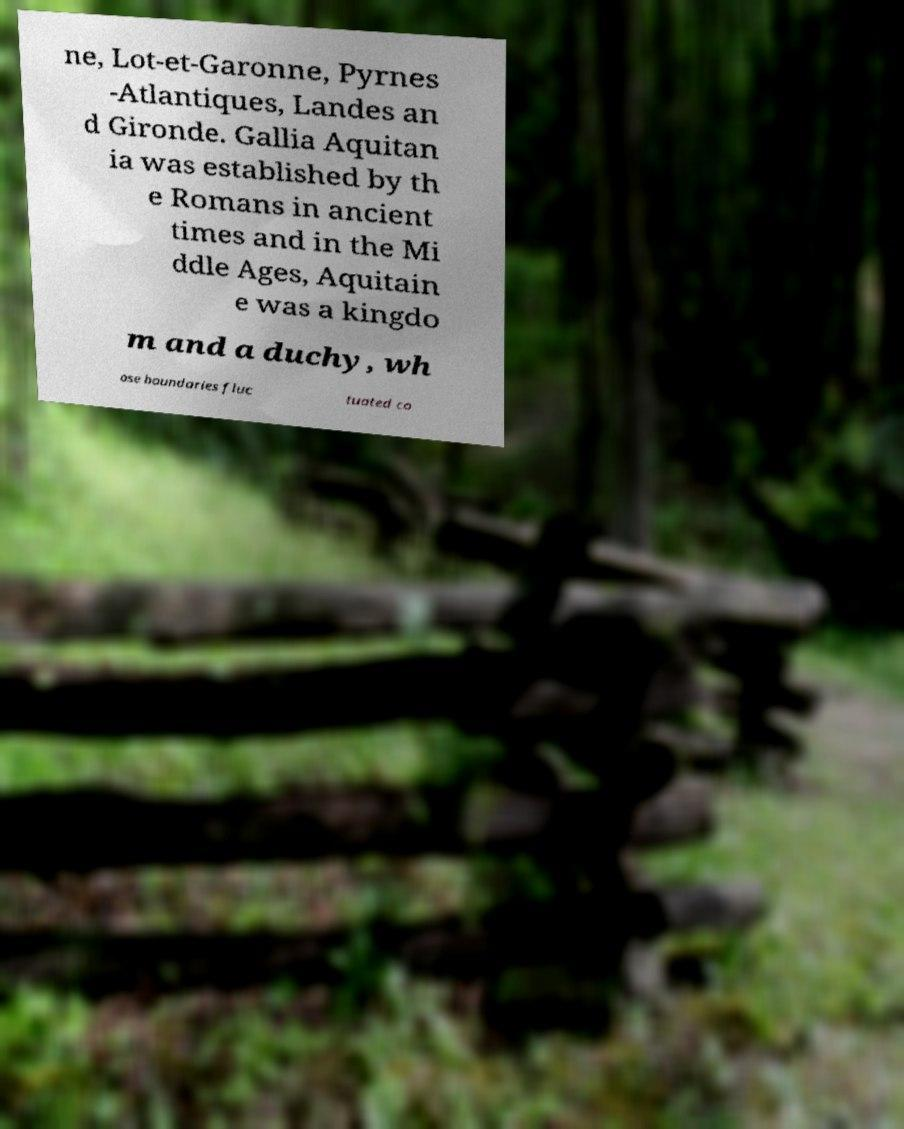Please identify and transcribe the text found in this image. ne, Lot-et-Garonne, Pyrnes -Atlantiques, Landes an d Gironde. Gallia Aquitan ia was established by th e Romans in ancient times and in the Mi ddle Ages, Aquitain e was a kingdo m and a duchy, wh ose boundaries fluc tuated co 